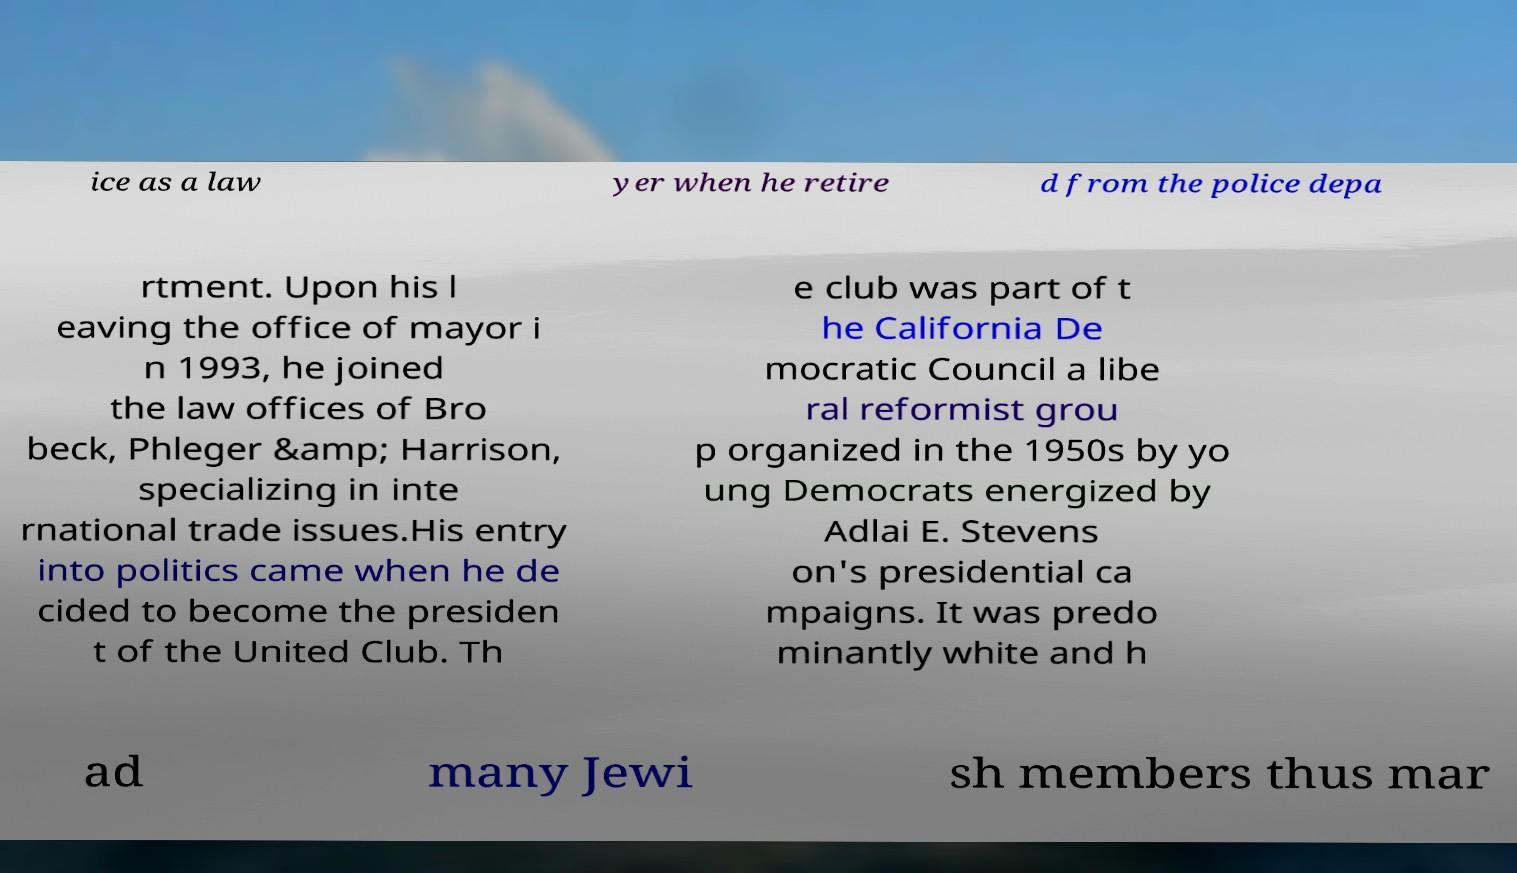For documentation purposes, I need the text within this image transcribed. Could you provide that? ice as a law yer when he retire d from the police depa rtment. Upon his l eaving the office of mayor i n 1993, he joined the law offices of Bro beck, Phleger &amp; Harrison, specializing in inte rnational trade issues.His entry into politics came when he de cided to become the presiden t of the United Club. Th e club was part of t he California De mocratic Council a libe ral reformist grou p organized in the 1950s by yo ung Democrats energized by Adlai E. Stevens on's presidential ca mpaigns. It was predo minantly white and h ad many Jewi sh members thus mar 